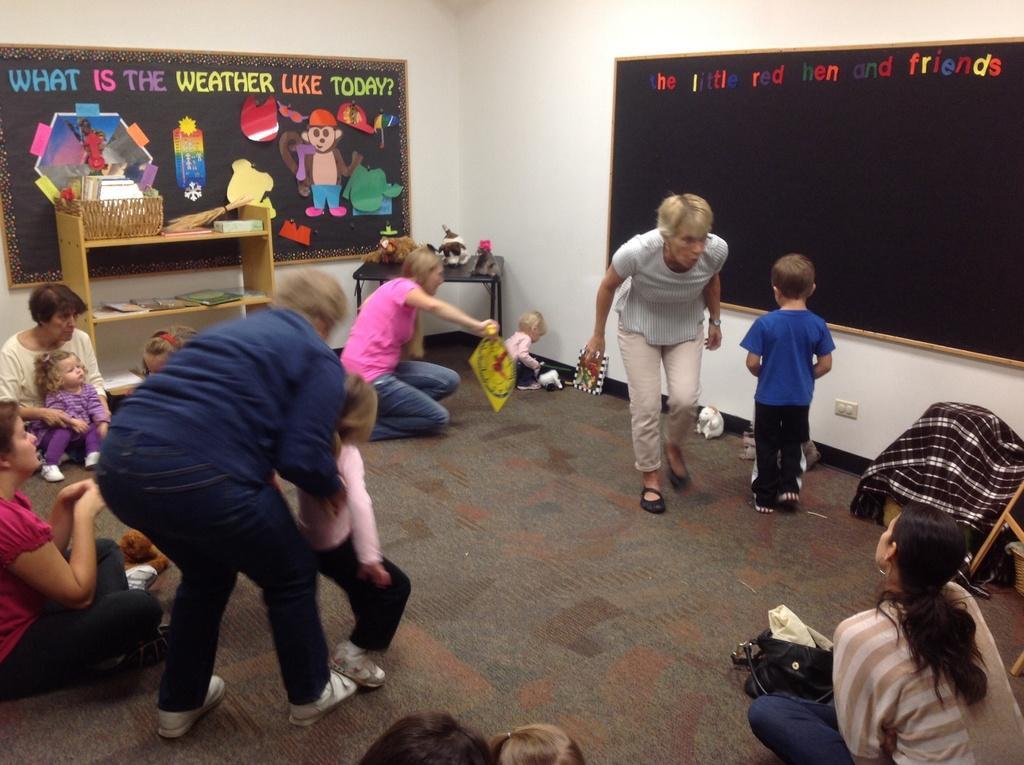Describe this image in one or two sentences. In this image I can see few people are sitting and few are standing. They are wearing different color dresses. I can see few books and few objects on the rack. I can see two black boards attached to the white wall. 